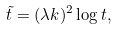<formula> <loc_0><loc_0><loc_500><loc_500>\tilde { t } = ( \lambda k ) ^ { 2 } \log t ,</formula> 